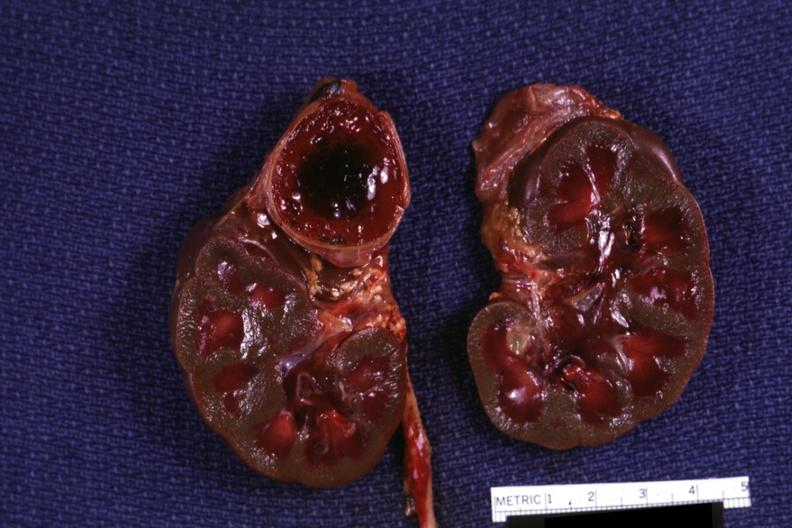do section of both kidneys and adrenals hemorrhage on one side kidneys are jaundiced?
Answer the question using a single word or phrase. Yes 